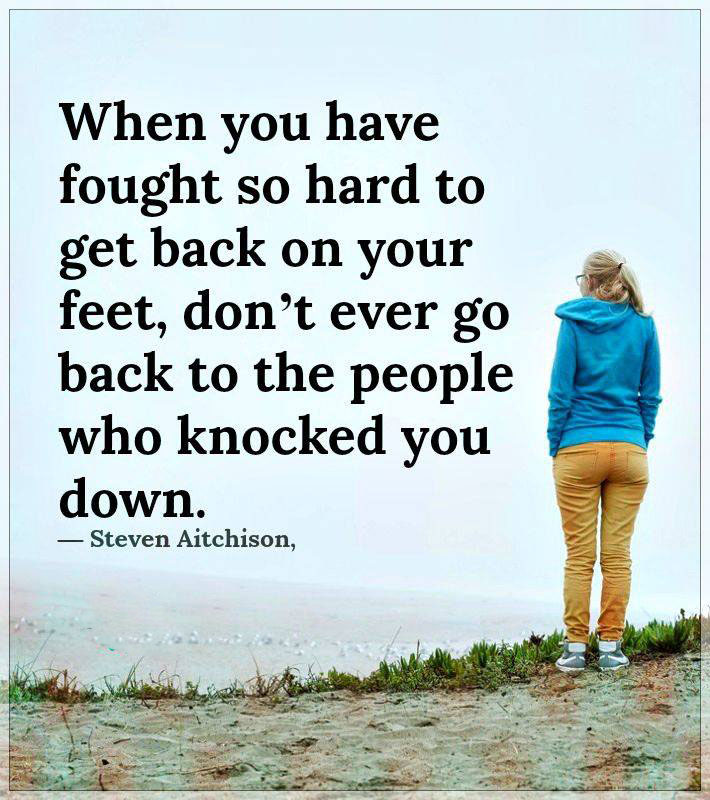Considering the atmospheric conditions and attire of the person in the image, what might be the season and time of day when this photo was taken? Observing the person's attire, which consists of long pants and a hoodie, the scene suggests a cooler climate, most likely in either spring or autumn. The overcast sky and presence of mist hint that it could be early morning or late afternoon, periods when fog is more common especially around coastal areas. However, without explicit sun positioning or shadows to confirm, we can infer but not definitively conclude the exact time of day. 